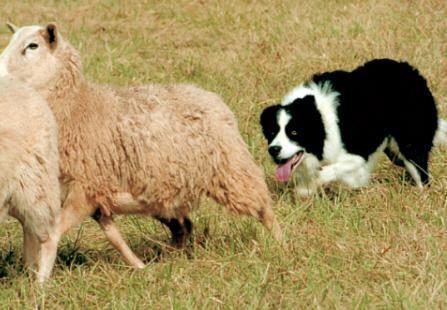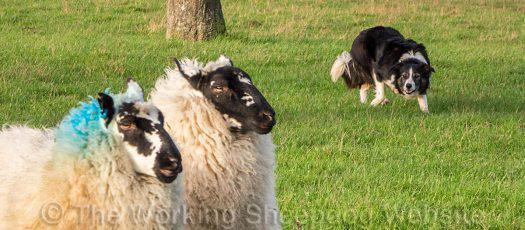The first image is the image on the left, the second image is the image on the right. Analyze the images presented: Is the assertion "Colored dye is visible on sheep's wool in the right image." valid? Answer yes or no. Yes. The first image is the image on the left, the second image is the image on the right. Analyze the images presented: Is the assertion "There are at least two dogs in the image on the left." valid? Answer yes or no. No. 